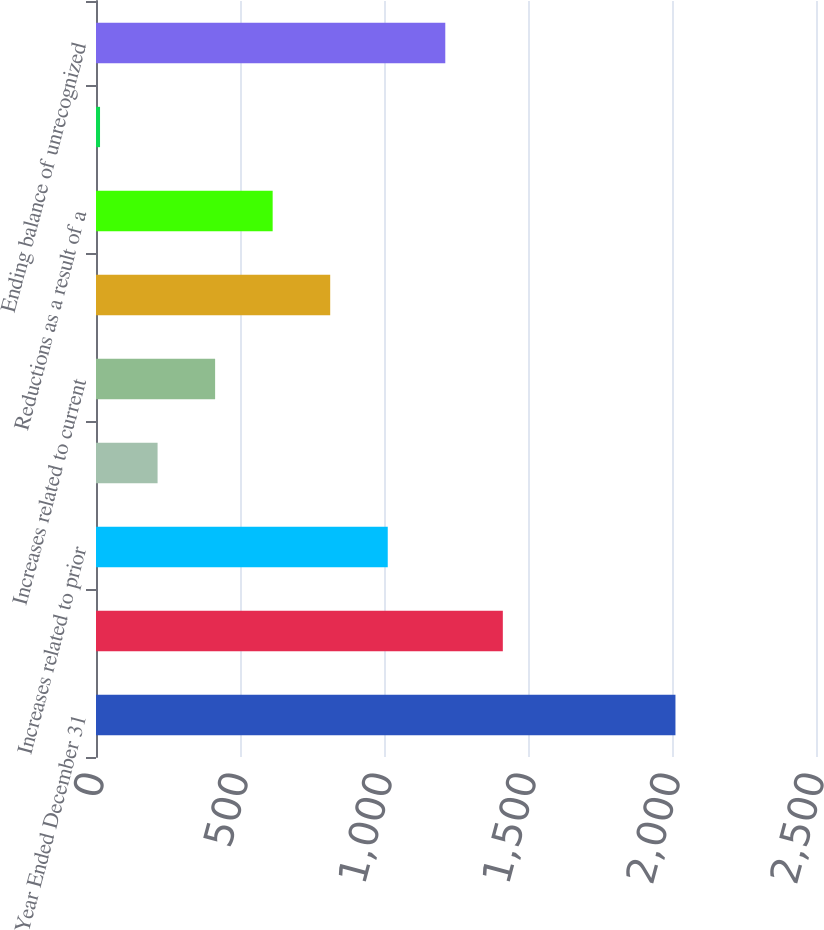Convert chart. <chart><loc_0><loc_0><loc_500><loc_500><bar_chart><fcel>Year Ended December 31<fcel>Beginning balance of<fcel>Increases related to prior<fcel>Decreases related to prior<fcel>Increases related to current<fcel>Decreases related to<fcel>Reductions as a result of a<fcel>Increases (decreases) from<fcel>Ending balance of unrecognized<nl><fcel>2012<fcel>1412.6<fcel>1013<fcel>213.8<fcel>413.6<fcel>813.2<fcel>613.4<fcel>14<fcel>1212.8<nl></chart> 